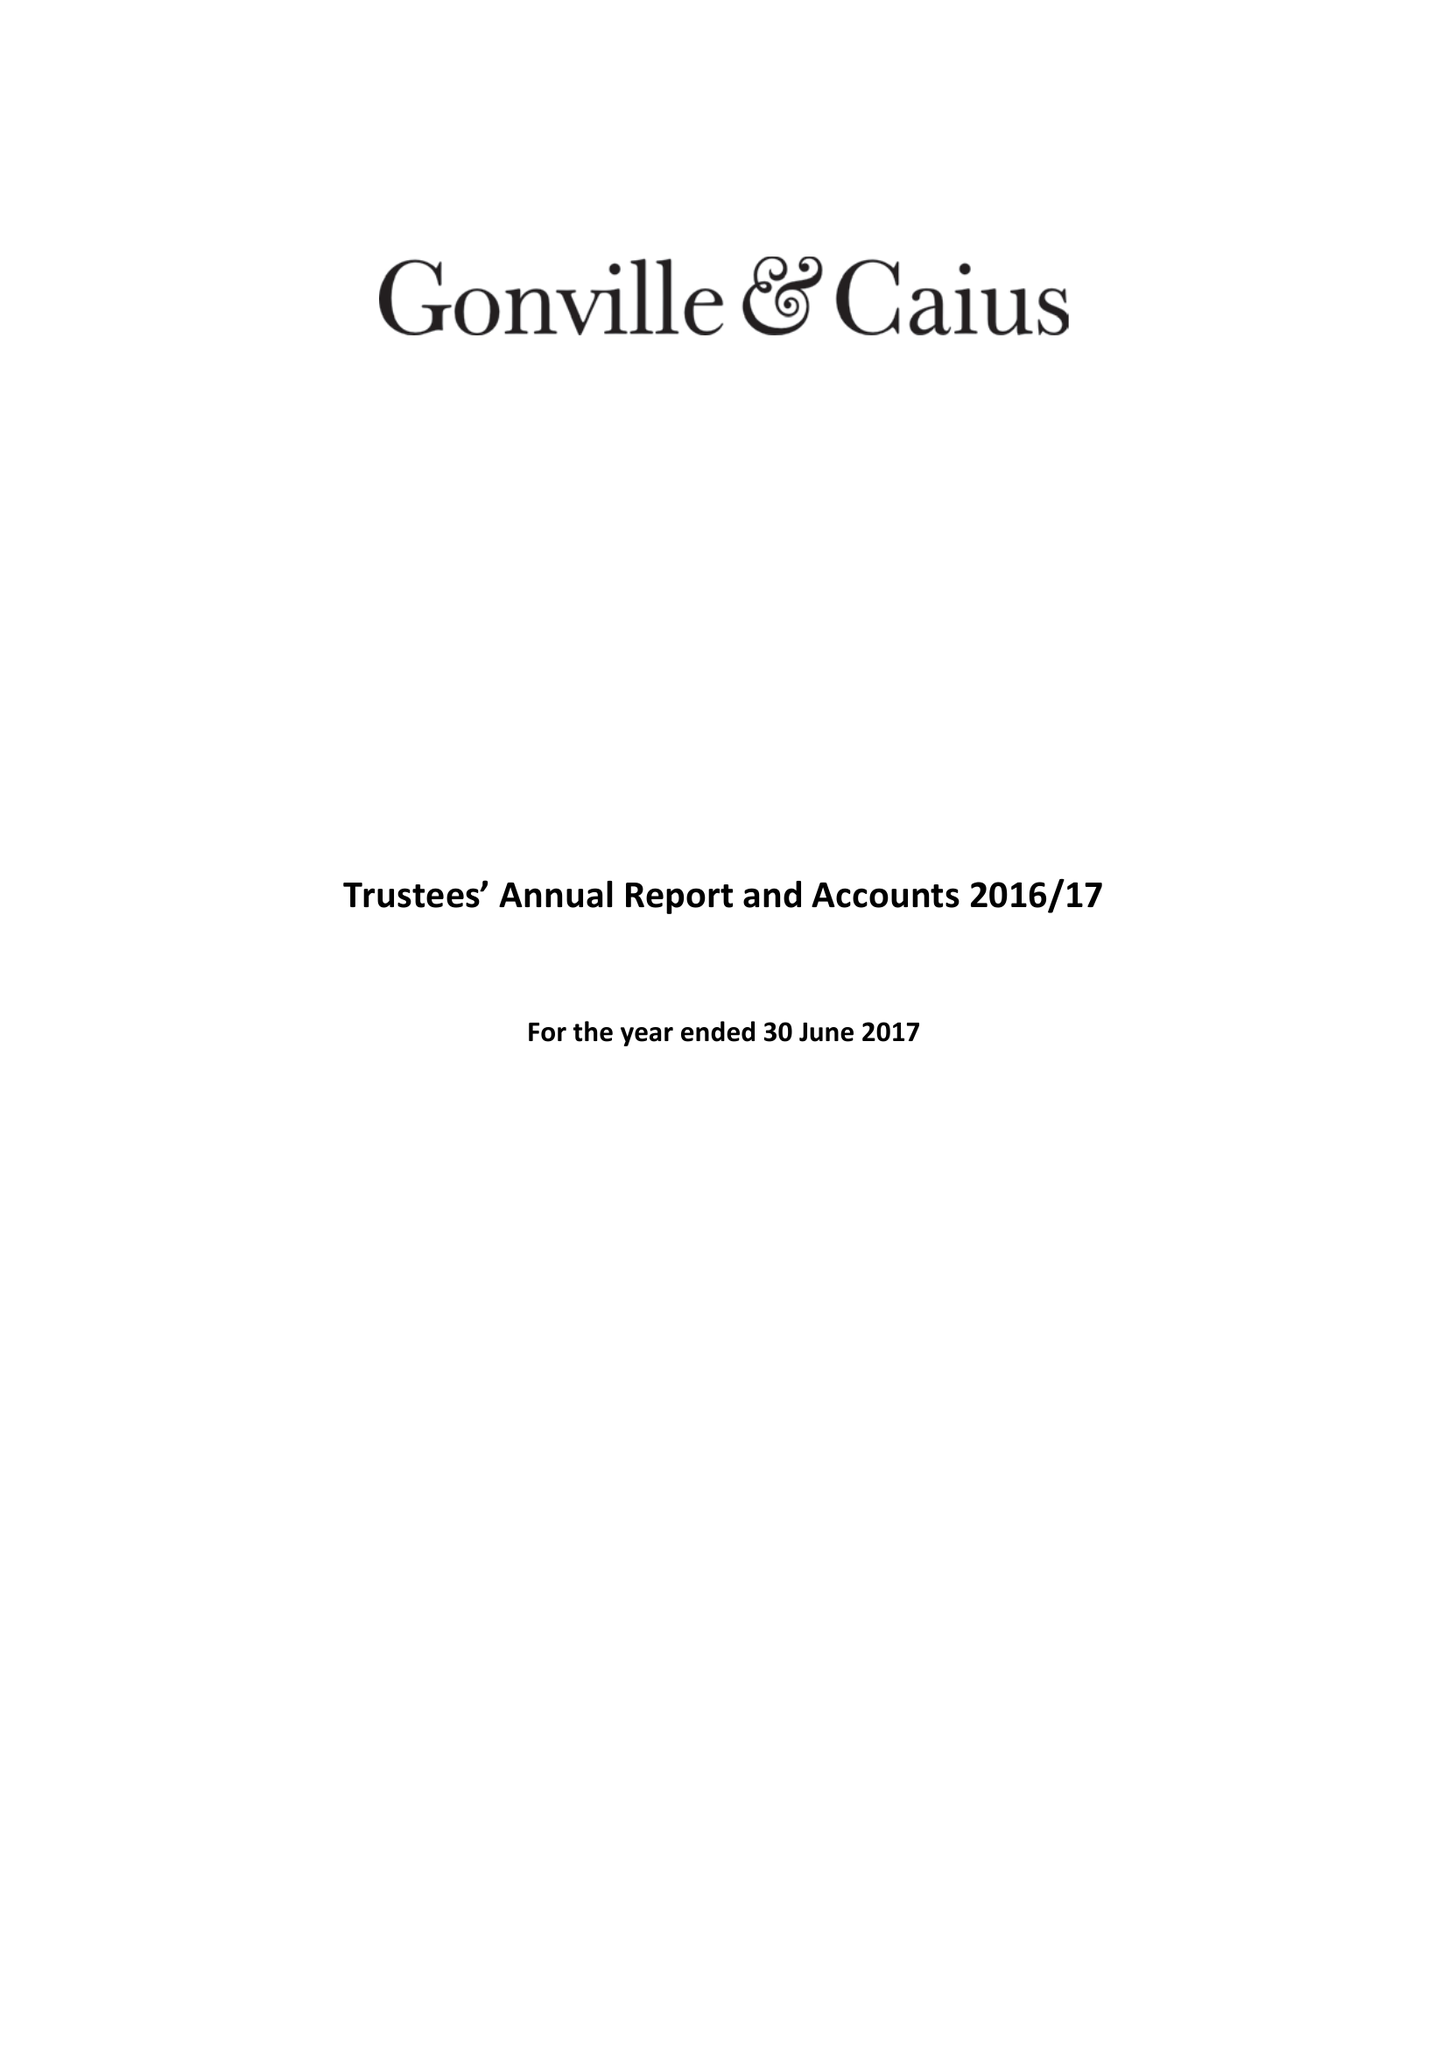What is the value for the address__postcode?
Answer the question using a single word or phrase. CB2 1TA 